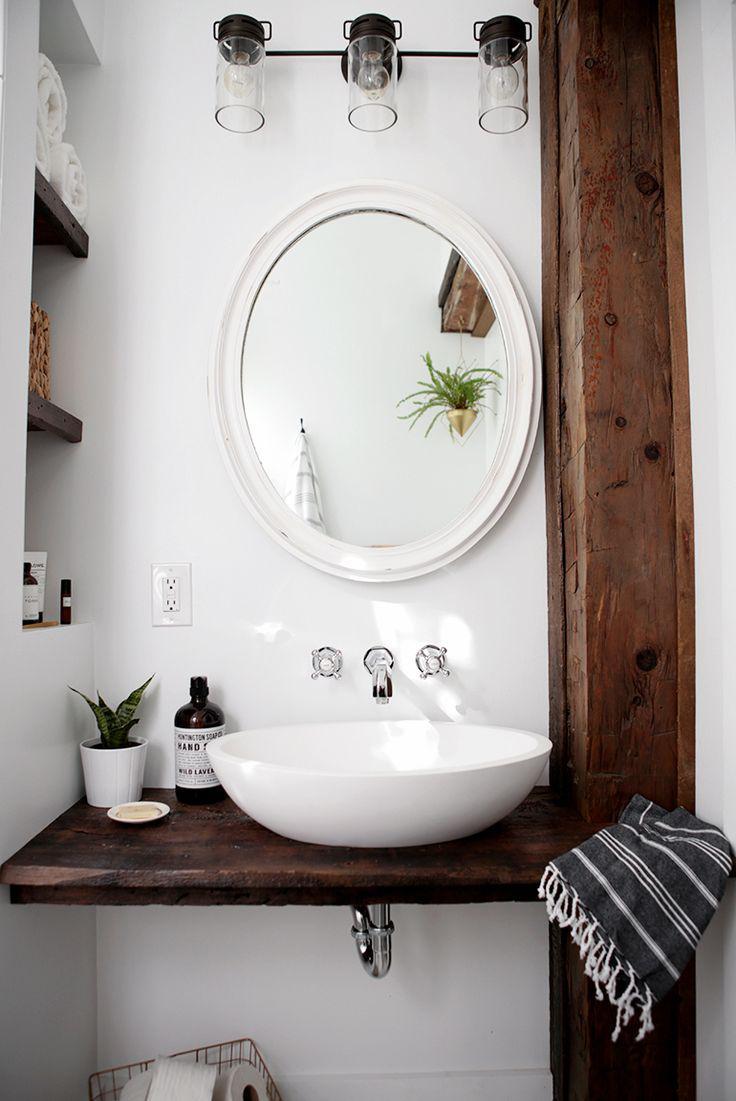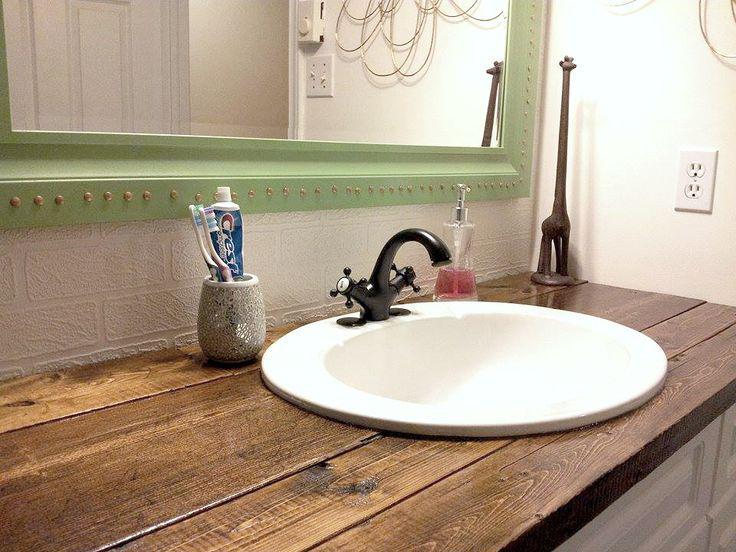The first image is the image on the left, the second image is the image on the right. For the images shown, is this caption "The sink in the image on the right is set in the counter." true? Answer yes or no. Yes. The first image is the image on the left, the second image is the image on the right. For the images shown, is this caption "In one image a round white sink with dark faucets and curved spout is set into a wooden-topped bathroom vanity." true? Answer yes or no. Yes. 